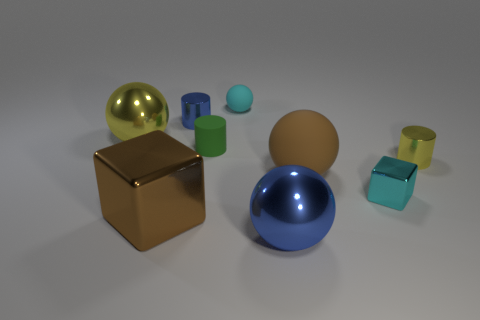There is a cube that is the same size as the green rubber cylinder; what is it made of?
Your response must be concise. Metal. There is another object that is the same color as the large matte thing; what is it made of?
Provide a short and direct response. Metal. What is the shape of the yellow metal object to the left of the blue cylinder?
Provide a succinct answer. Sphere. What color is the small block that is made of the same material as the large cube?
Make the answer very short. Cyan. The other rubber thing that is the same shape as the cyan matte thing is what color?
Your response must be concise. Brown. Does the brown thing on the right side of the big brown metal block have the same material as the green cylinder?
Your response must be concise. Yes. There is a cube that is right of the metal thing in front of the large brown shiny object; what is its material?
Your response must be concise. Metal. Is the number of blue cylinders that are to the left of the tiny block greater than the number of small yellow objects on the right side of the yellow metal cylinder?
Provide a short and direct response. Yes. What is the size of the green thing?
Offer a very short reply. Small. There is a rubber thing that is in front of the tiny yellow metal thing; does it have the same color as the large metal block?
Your answer should be compact. Yes. 